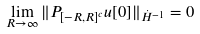Convert formula to latex. <formula><loc_0><loc_0><loc_500><loc_500>\lim _ { R \to \infty } \| P _ { [ - R , R ] ^ { c } } u [ 0 ] \| _ { \dot { H } ^ { - 1 } } = 0</formula> 